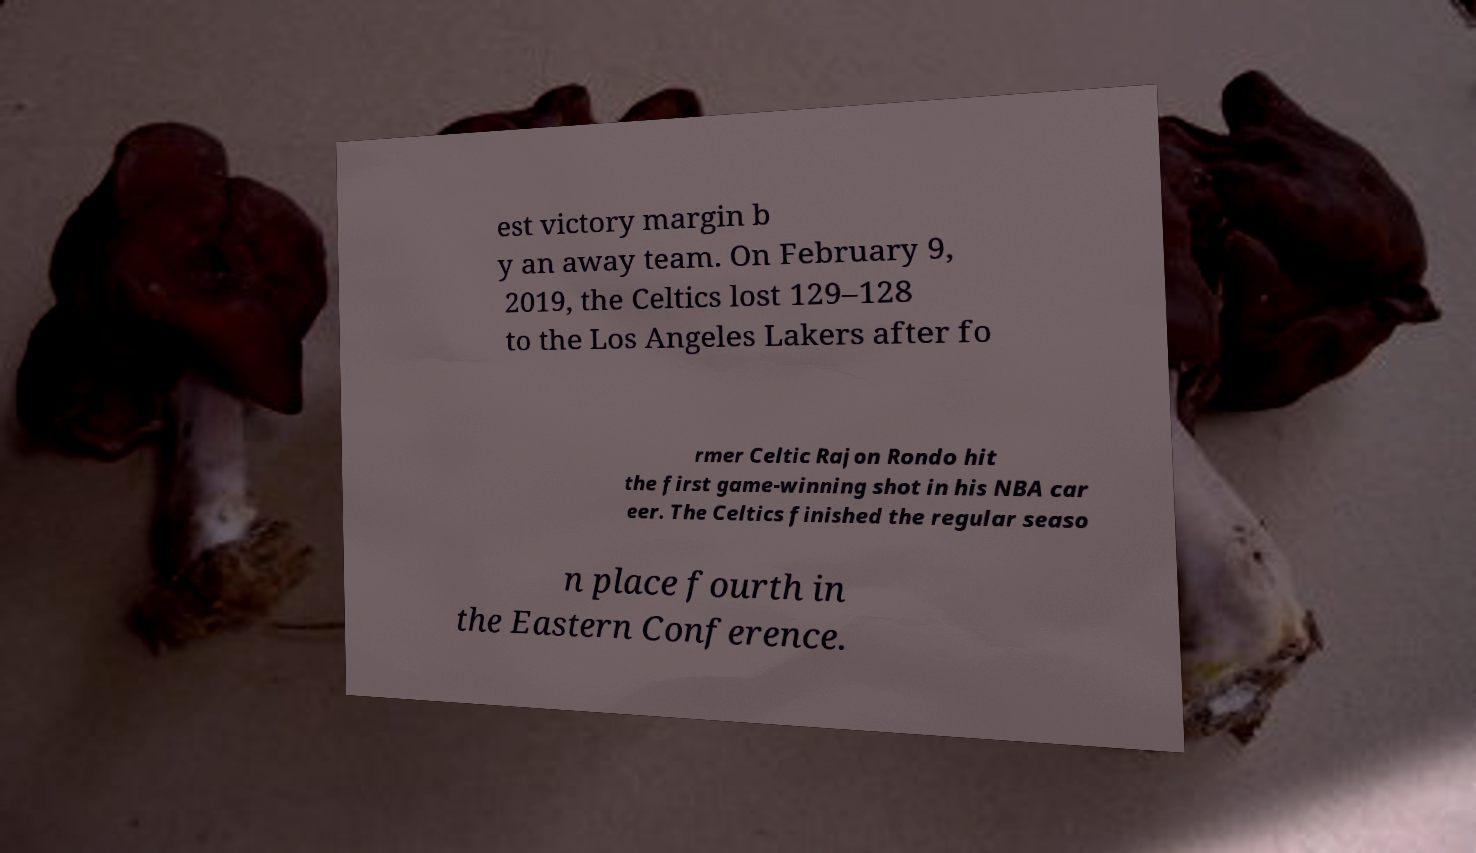There's text embedded in this image that I need extracted. Can you transcribe it verbatim? est victory margin b y an away team. On February 9, 2019, the Celtics lost 129–128 to the Los Angeles Lakers after fo rmer Celtic Rajon Rondo hit the first game-winning shot in his NBA car eer. The Celtics finished the regular seaso n place fourth in the Eastern Conference. 